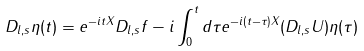<formula> <loc_0><loc_0><loc_500><loc_500>D _ { l , s } \eta ( t ) = e ^ { - i t X } D _ { l , s } f - i \int _ { 0 } ^ { t } d \tau e ^ { - i ( t - \tau ) X } ( D _ { l , s } U ) \eta ( \tau )</formula> 